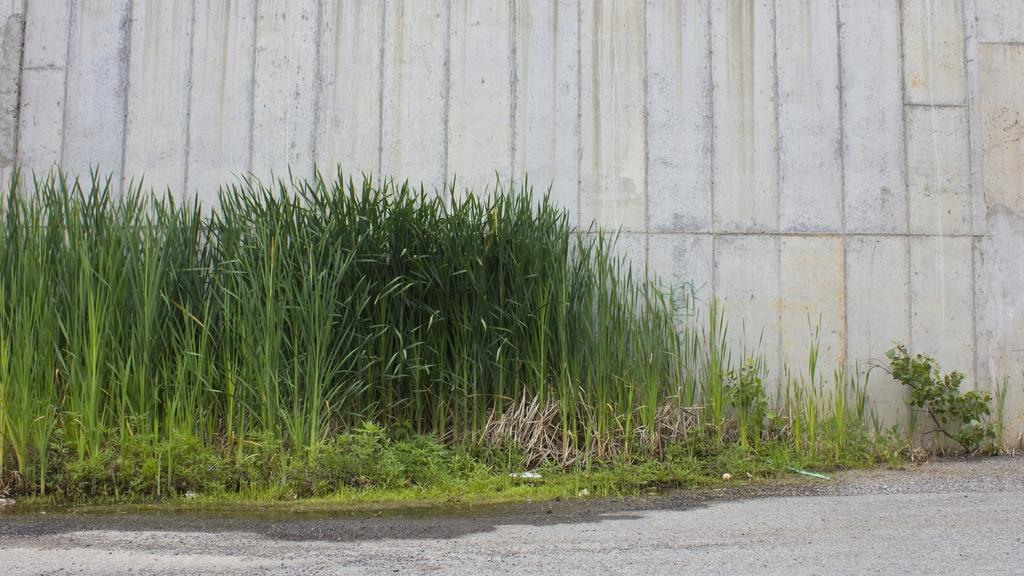What type of living organisms can be seen in the image? Plants can be seen in the image. What is visible at the back of the image? There is a wall at the back of the image. What type of band is performing in the image? There is no band present in the image; it only features plants and a wall. 